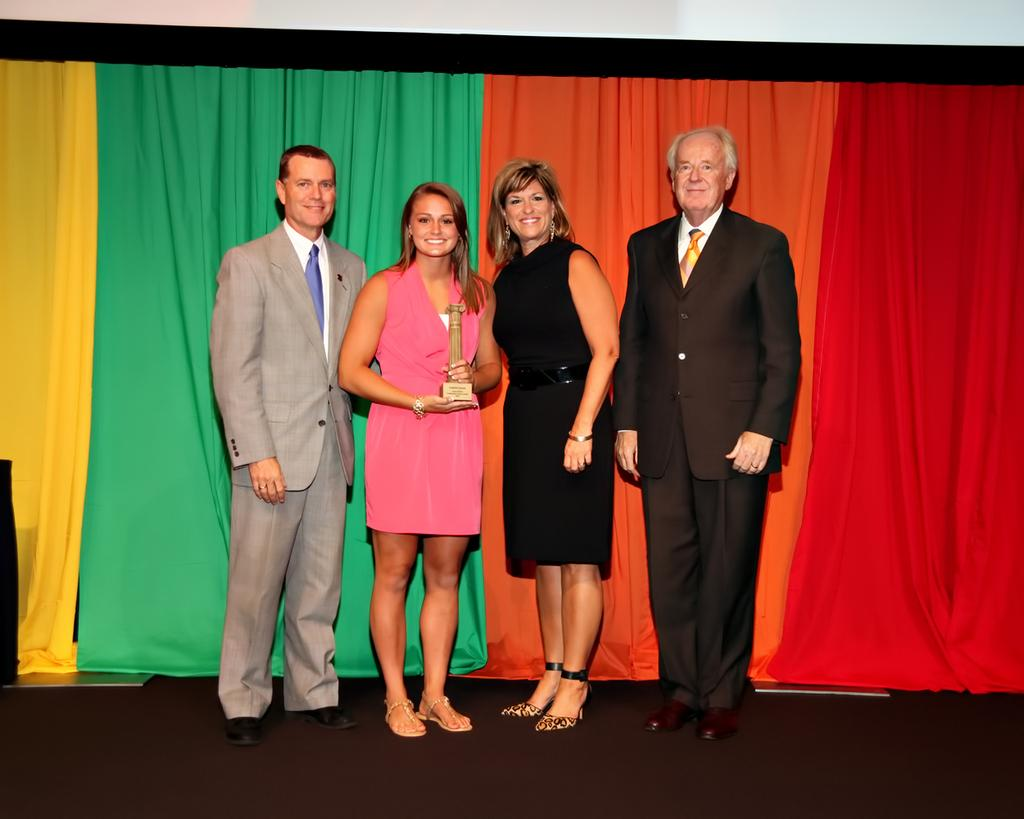How many people are present in the image? There are four people standing in the image. What are the people doing in the image? The people are standing on the floor and smiling. What can be seen in the background of the image? There are curtains visible in the background of the image. What role does the creator play in the image? There is no mention of a creator in the image, so it is not possible to determine their role. 